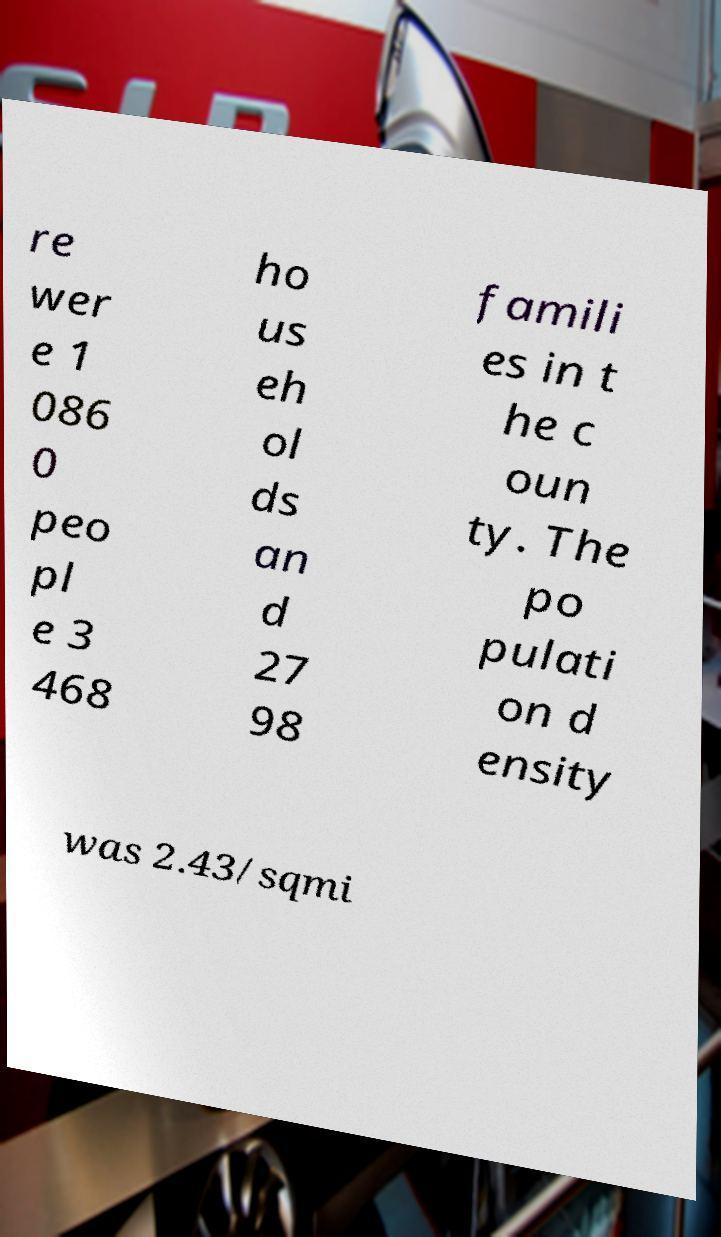I need the written content from this picture converted into text. Can you do that? re wer e 1 086 0 peo pl e 3 468 ho us eh ol ds an d 27 98 famili es in t he c oun ty. The po pulati on d ensity was 2.43/sqmi 